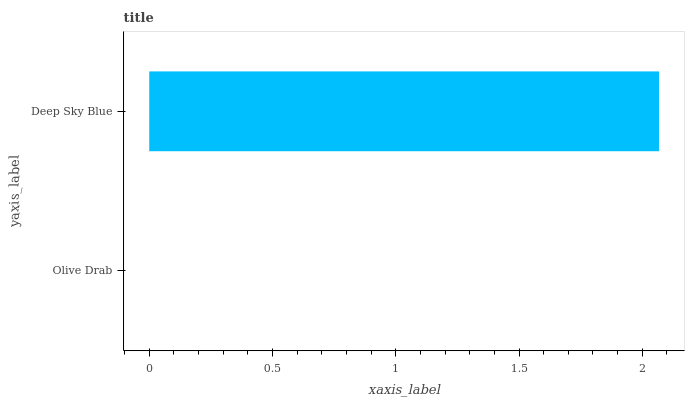Is Olive Drab the minimum?
Answer yes or no. Yes. Is Deep Sky Blue the maximum?
Answer yes or no. Yes. Is Deep Sky Blue the minimum?
Answer yes or no. No. Is Deep Sky Blue greater than Olive Drab?
Answer yes or no. Yes. Is Olive Drab less than Deep Sky Blue?
Answer yes or no. Yes. Is Olive Drab greater than Deep Sky Blue?
Answer yes or no. No. Is Deep Sky Blue less than Olive Drab?
Answer yes or no. No. Is Deep Sky Blue the high median?
Answer yes or no. Yes. Is Olive Drab the low median?
Answer yes or no. Yes. Is Olive Drab the high median?
Answer yes or no. No. Is Deep Sky Blue the low median?
Answer yes or no. No. 